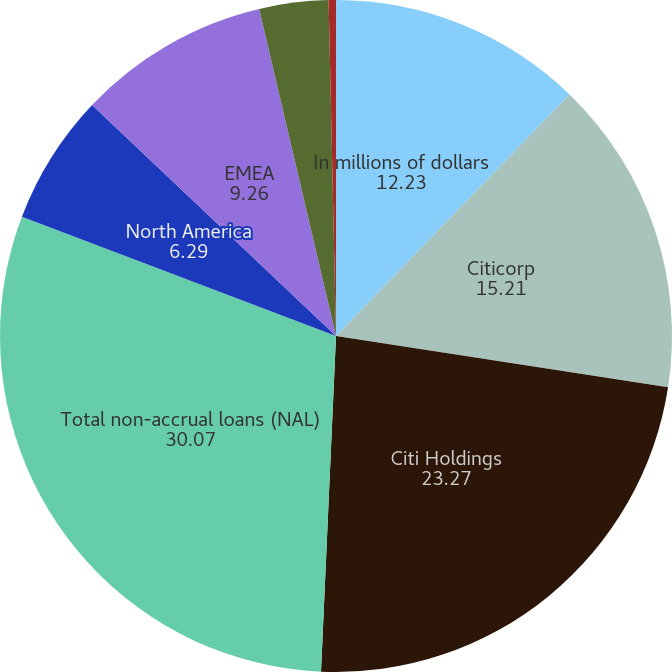Convert chart to OTSL. <chart><loc_0><loc_0><loc_500><loc_500><pie_chart><fcel>In millions of dollars<fcel>Citicorp<fcel>Citi Holdings<fcel>Total non-accrual loans (NAL)<fcel>North America<fcel>EMEA<fcel>Latin America<fcel>Asia<nl><fcel>12.23%<fcel>15.21%<fcel>23.27%<fcel>30.07%<fcel>6.29%<fcel>9.26%<fcel>3.32%<fcel>0.35%<nl></chart> 